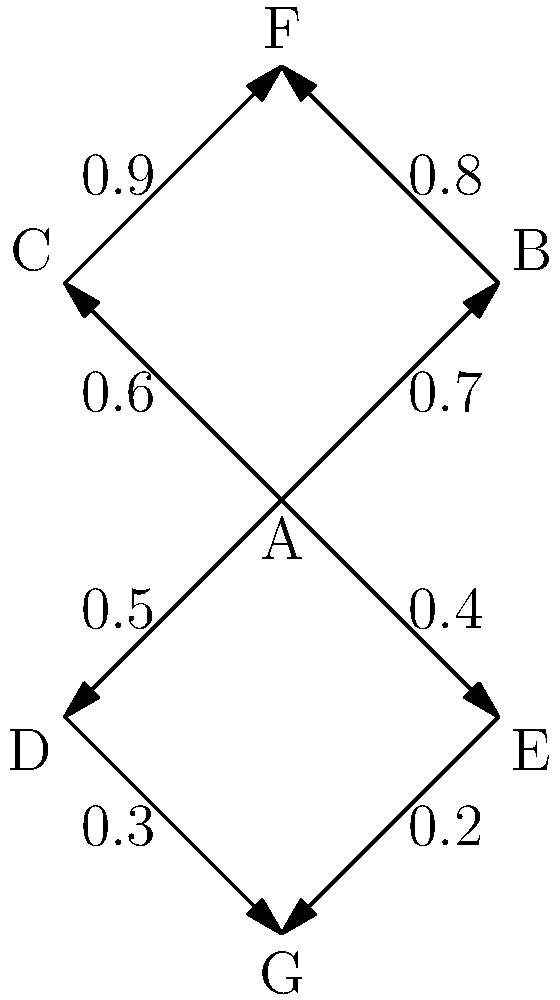In the network graph representing the spread of a new health policy across different states, each vertex represents a state, and each directed edge represents the influence one state has on another in adopting the policy. The weight on each edge represents the probability of policy adoption. What is the probability that the policy will spread from State A to State G through the path with the highest likelihood of adoption? To find the path with the highest likelihood of policy adoption from State A to State G, we need to:

1. Identify all possible paths from A to G:
   - A → D → G
   - A → E → G

2. Calculate the probability of each path:
   - For A → D → G: $P(A\to D\to G) = 0.5 \times 0.3 = 0.15$
   - For A → E → G: $P(A\to E\to G) = 0.4 \times 0.2 = 0.08$

3. Compare the probabilities:
   $0.15 > 0.08$

4. Select the path with the highest probability:
   A → D → G with a probability of 0.15

The probability of the policy spreading from State A to State G through the path with the highest likelihood of adoption is 0.15 or 15%.
Answer: 0.15 